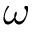<formula> <loc_0><loc_0><loc_500><loc_500>\omega</formula> 